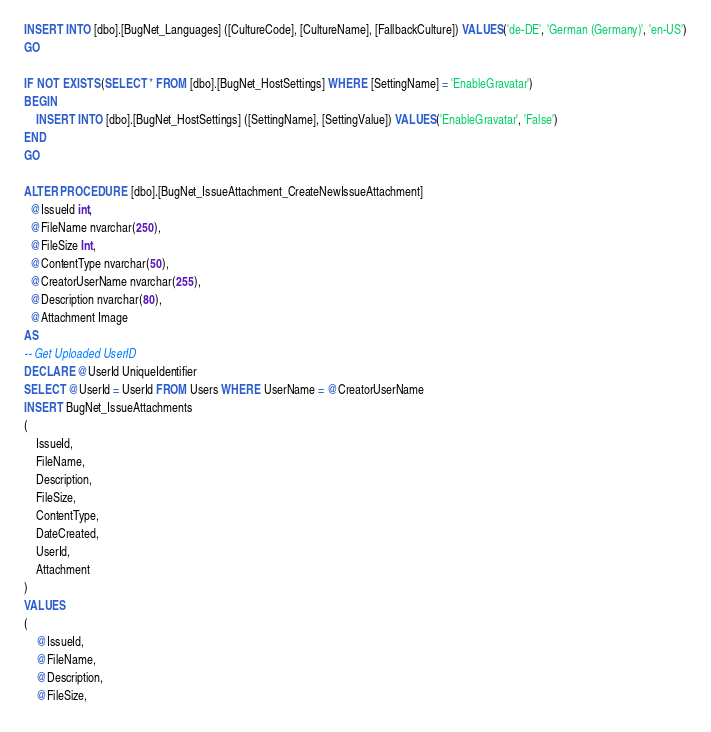<code> <loc_0><loc_0><loc_500><loc_500><_SQL_>INSERT INTO [dbo].[BugNet_Languages] ([CultureCode], [CultureName], [FallbackCulture]) VALUES('de-DE', 'German (Germany)', 'en-US')
GO

IF NOT EXISTS(SELECT * FROM [dbo].[BugNet_HostSettings] WHERE [SettingName] = 'EnableGravatar')
BEGIN
    INSERT INTO [dbo].[BugNet_HostSettings] ([SettingName], [SettingValue]) VALUES('EnableGravatar', 'False')
END
GO

ALTER PROCEDURE [dbo].[BugNet_IssueAttachment_CreateNewIssueAttachment]
  @IssueId int,
  @FileName nvarchar(250),
  @FileSize Int,
  @ContentType nvarchar(50),
  @CreatorUserName nvarchar(255),
  @Description nvarchar(80),
  @Attachment Image
AS
-- Get Uploaded UserID
DECLARE @UserId UniqueIdentifier
SELECT @UserId = UserId FROM Users WHERE UserName = @CreatorUserName
INSERT BugNet_IssueAttachments
(
	IssueId,
	FileName,
	Description,
	FileSize,
	ContentType,
	DateCreated,
	UserId,
	Attachment
)
VALUES
(
	@IssueId,
	@FileName,
	@Description,
	@FileSize,</code> 